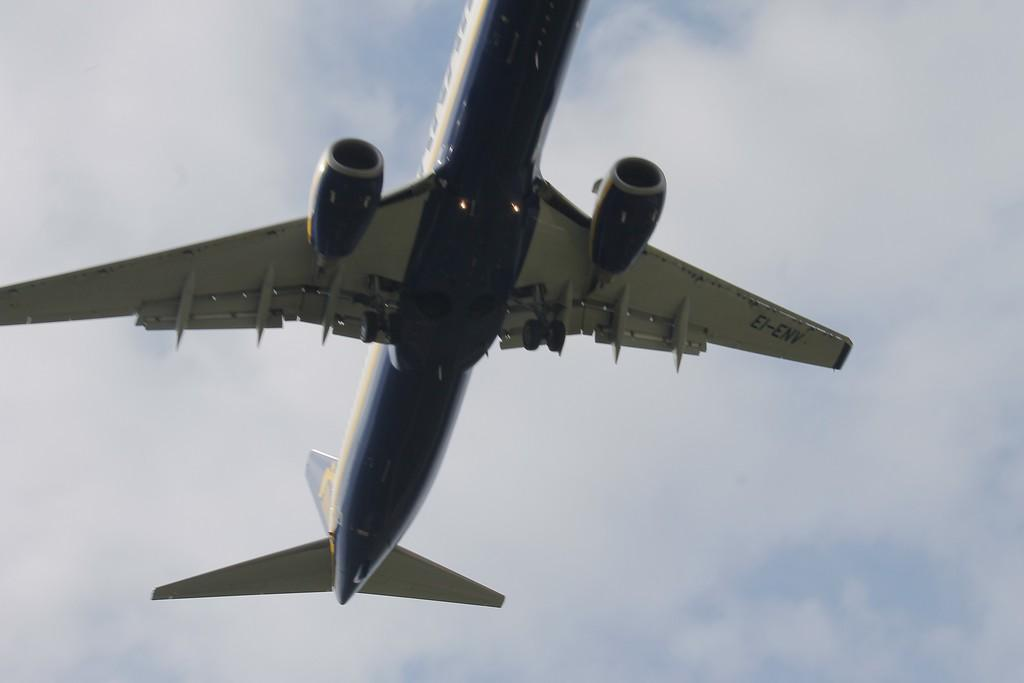What is the main subject of the image? The main subject of the image is an airplane. Where is the airplane located in the image? The airplane is in the center of the image. What can be seen in the background of the image? There are clouds and the sky visible in the background of the image. Can you tell me how many chickens are sitting on the wing of the airplane in the image? There are no chickens present on the airplane in the image. What type of wine is being served on the airplane in the image? There is no wine visible in the image, as it features an airplane with no visible passengers or service. 